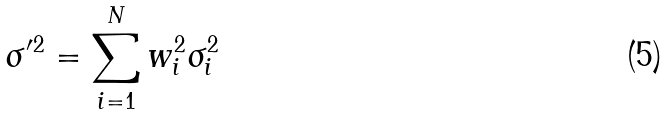Convert formula to latex. <formula><loc_0><loc_0><loc_500><loc_500>\sigma ^ { \prime 2 } = \sum _ { i = 1 } ^ { N } w ^ { 2 } _ { i } \sigma ^ { 2 } _ { i }</formula> 